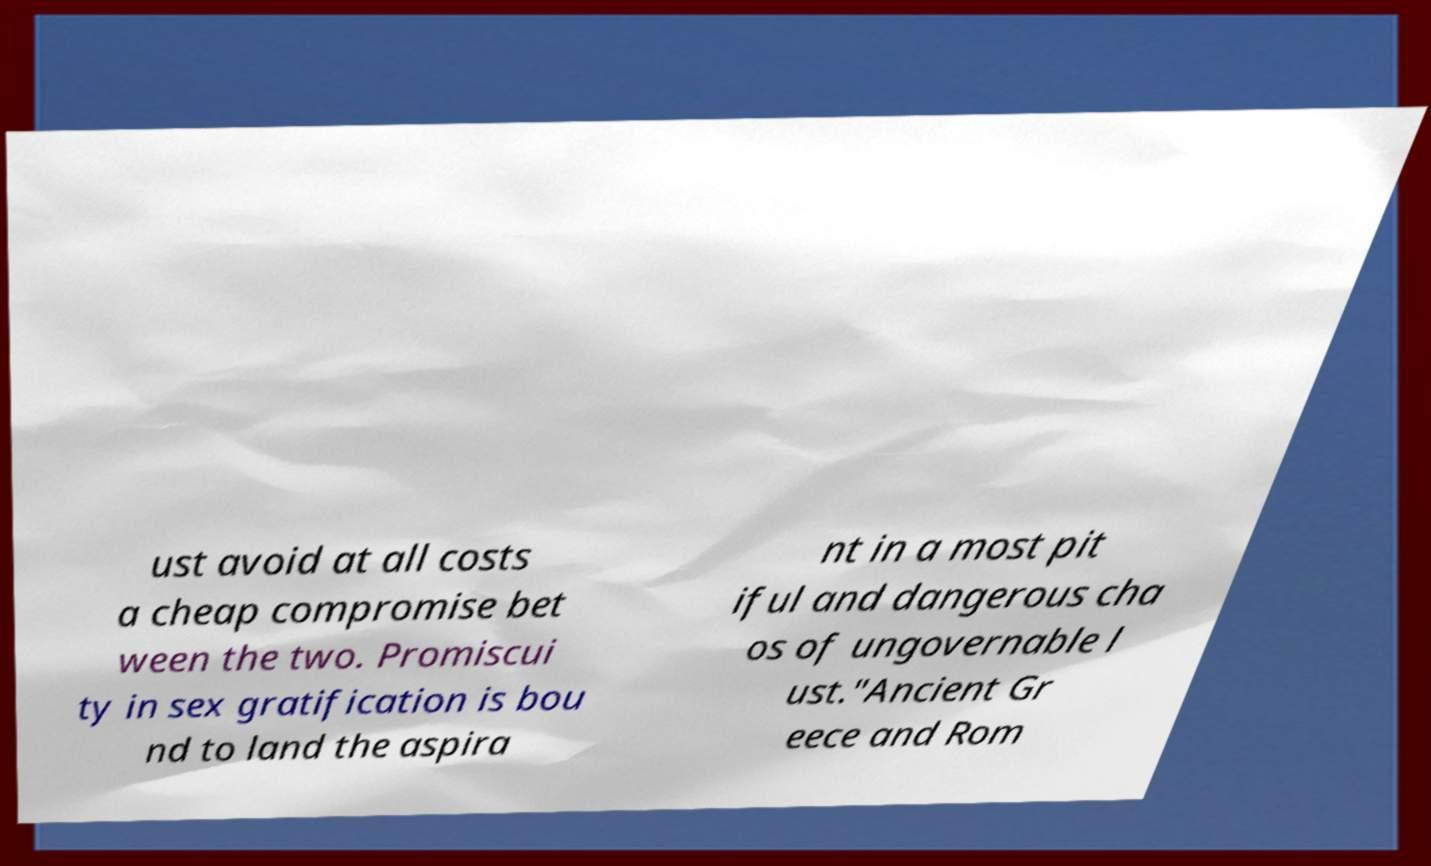I need the written content from this picture converted into text. Can you do that? ust avoid at all costs a cheap compromise bet ween the two. Promiscui ty in sex gratification is bou nd to land the aspira nt in a most pit iful and dangerous cha os of ungovernable l ust."Ancient Gr eece and Rom 